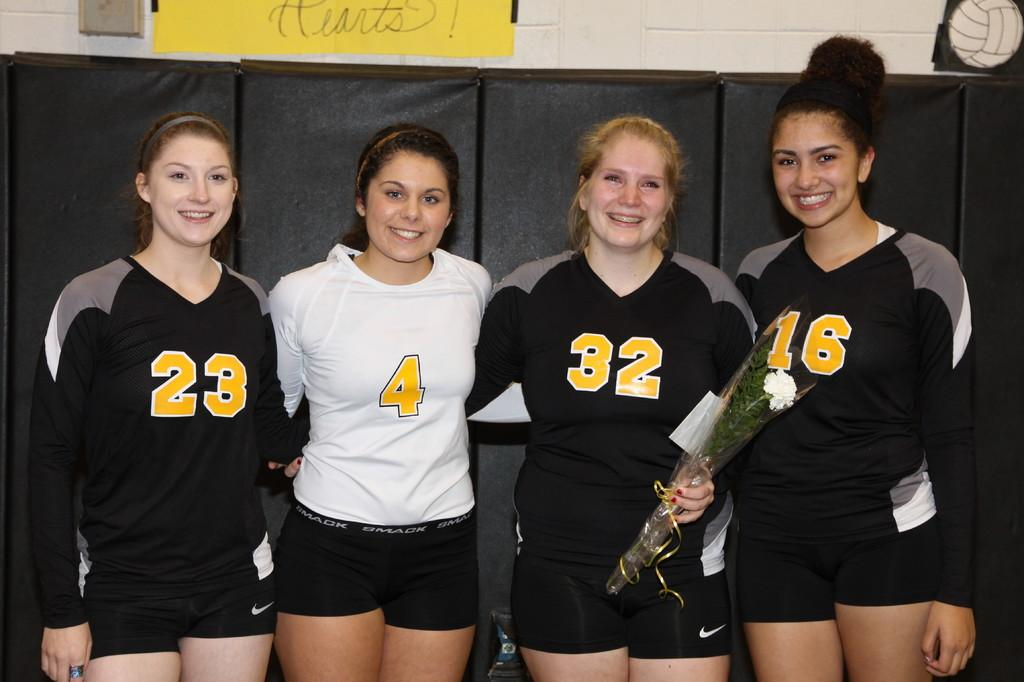<image>
Render a clear and concise summary of the photo. Female volleyball player 32 holding a carnation in plastic, flanked by other members numbers 23, 4, and 16. 